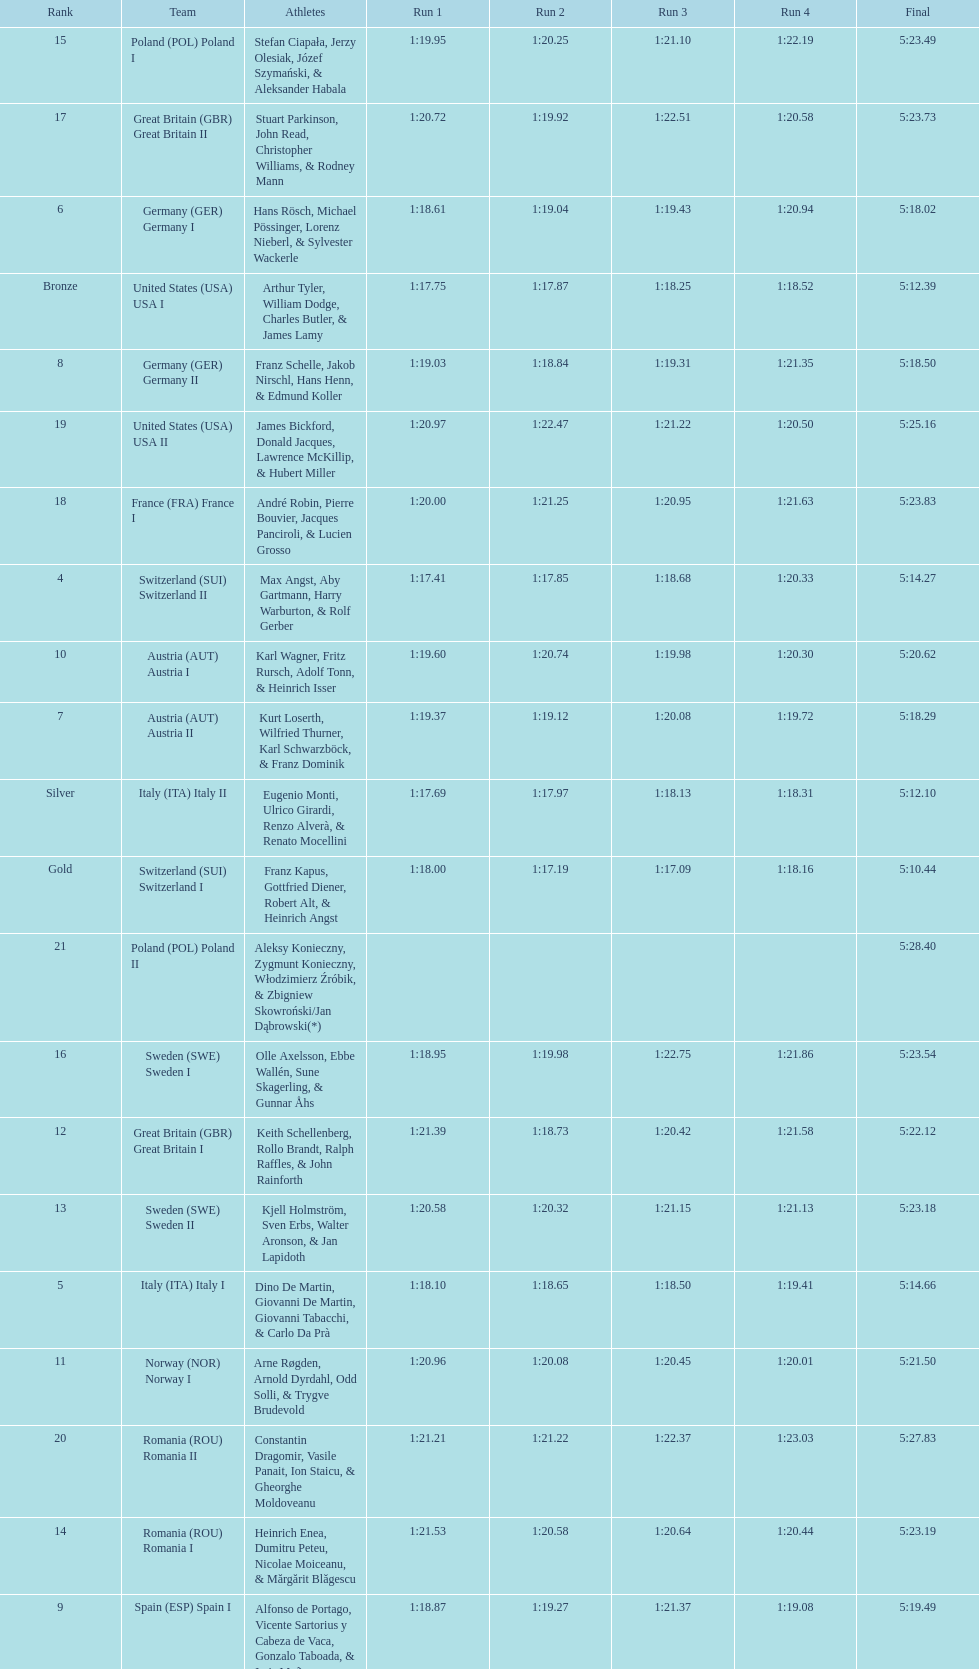What team came out on top? Switzerland. 